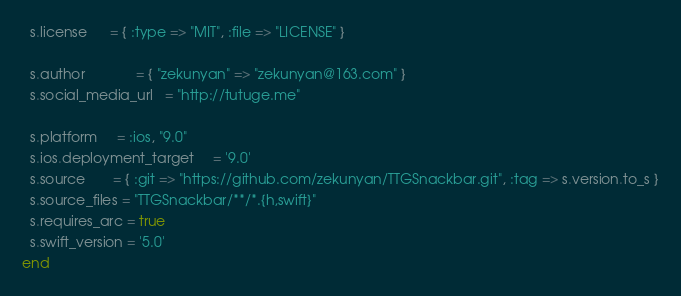Convert code to text. <code><loc_0><loc_0><loc_500><loc_500><_Ruby_>  s.license      = { :type => "MIT", :file => "LICENSE" }

  s.author             = { "zekunyan" => "zekunyan@163.com" }
  s.social_media_url   = "http://tutuge.me"

  s.platform     = :ios, "9.0"
  s.ios.deployment_target     = '9.0'
  s.source       = { :git => "https://github.com/zekunyan/TTGSnackbar.git", :tag => s.version.to_s }
  s.source_files = "TTGSnackbar/**/*.{h,swift}"
  s.requires_arc = true
  s.swift_version = '5.0'
end
</code> 